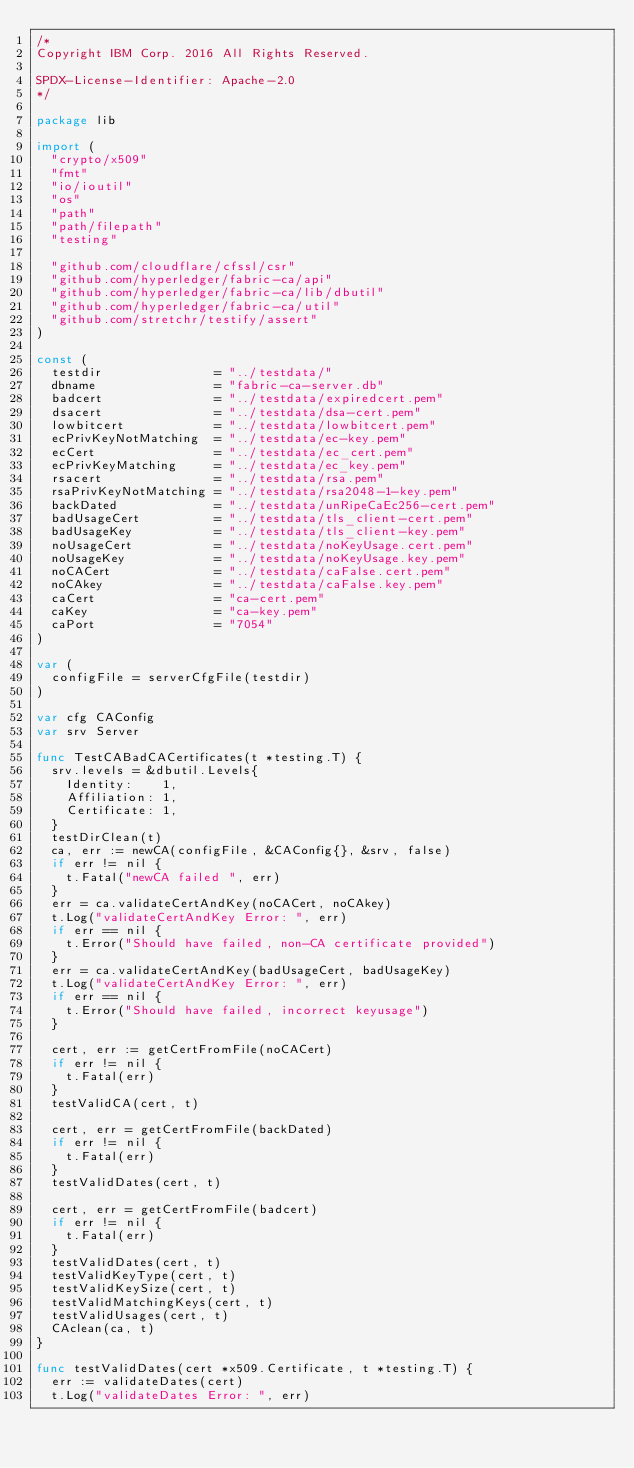<code> <loc_0><loc_0><loc_500><loc_500><_Go_>/*
Copyright IBM Corp. 2016 All Rights Reserved.

SPDX-License-Identifier: Apache-2.0
*/

package lib

import (
	"crypto/x509"
	"fmt"
	"io/ioutil"
	"os"
	"path"
	"path/filepath"
	"testing"

	"github.com/cloudflare/cfssl/csr"
	"github.com/hyperledger/fabric-ca/api"
	"github.com/hyperledger/fabric-ca/lib/dbutil"
	"github.com/hyperledger/fabric-ca/util"
	"github.com/stretchr/testify/assert"
)

const (
	testdir               = "../testdata/"
	dbname                = "fabric-ca-server.db"
	badcert               = "../testdata/expiredcert.pem"
	dsacert               = "../testdata/dsa-cert.pem"
	lowbitcert            = "../testdata/lowbitcert.pem"
	ecPrivKeyNotMatching  = "../testdata/ec-key.pem"
	ecCert                = "../testdata/ec_cert.pem"
	ecPrivKeyMatching     = "../testdata/ec_key.pem"
	rsacert               = "../testdata/rsa.pem"
	rsaPrivKeyNotMatching = "../testdata/rsa2048-1-key.pem"
	backDated             = "../testdata/unRipeCaEc256-cert.pem"
	badUsageCert          = "../testdata/tls_client-cert.pem"
	badUsageKey           = "../testdata/tls_client-key.pem"
	noUsageCert           = "../testdata/noKeyUsage.cert.pem"
	noUsageKey            = "../testdata/noKeyUsage.key.pem"
	noCACert              = "../testdata/caFalse.cert.pem"
	noCAkey               = "../testdata/caFalse.key.pem"
	caCert                = "ca-cert.pem"
	caKey                 = "ca-key.pem"
	caPort                = "7054"
)

var (
	configFile = serverCfgFile(testdir)
)

var cfg CAConfig
var srv Server

func TestCABadCACertificates(t *testing.T) {
	srv.levels = &dbutil.Levels{
		Identity:    1,
		Affiliation: 1,
		Certificate: 1,
	}
	testDirClean(t)
	ca, err := newCA(configFile, &CAConfig{}, &srv, false)
	if err != nil {
		t.Fatal("newCA failed ", err)
	}
	err = ca.validateCertAndKey(noCACert, noCAkey)
	t.Log("validateCertAndKey Error: ", err)
	if err == nil {
		t.Error("Should have failed, non-CA certificate provided")
	}
	err = ca.validateCertAndKey(badUsageCert, badUsageKey)
	t.Log("validateCertAndKey Error: ", err)
	if err == nil {
		t.Error("Should have failed, incorrect keyusage")
	}

	cert, err := getCertFromFile(noCACert)
	if err != nil {
		t.Fatal(err)
	}
	testValidCA(cert, t)

	cert, err = getCertFromFile(backDated)
	if err != nil {
		t.Fatal(err)
	}
	testValidDates(cert, t)

	cert, err = getCertFromFile(badcert)
	if err != nil {
		t.Fatal(err)
	}
	testValidDates(cert, t)
	testValidKeyType(cert, t)
	testValidKeySize(cert, t)
	testValidMatchingKeys(cert, t)
	testValidUsages(cert, t)
	CAclean(ca, t)
}

func testValidDates(cert *x509.Certificate, t *testing.T) {
	err := validateDates(cert)
	t.Log("validateDates Error: ", err)</code> 